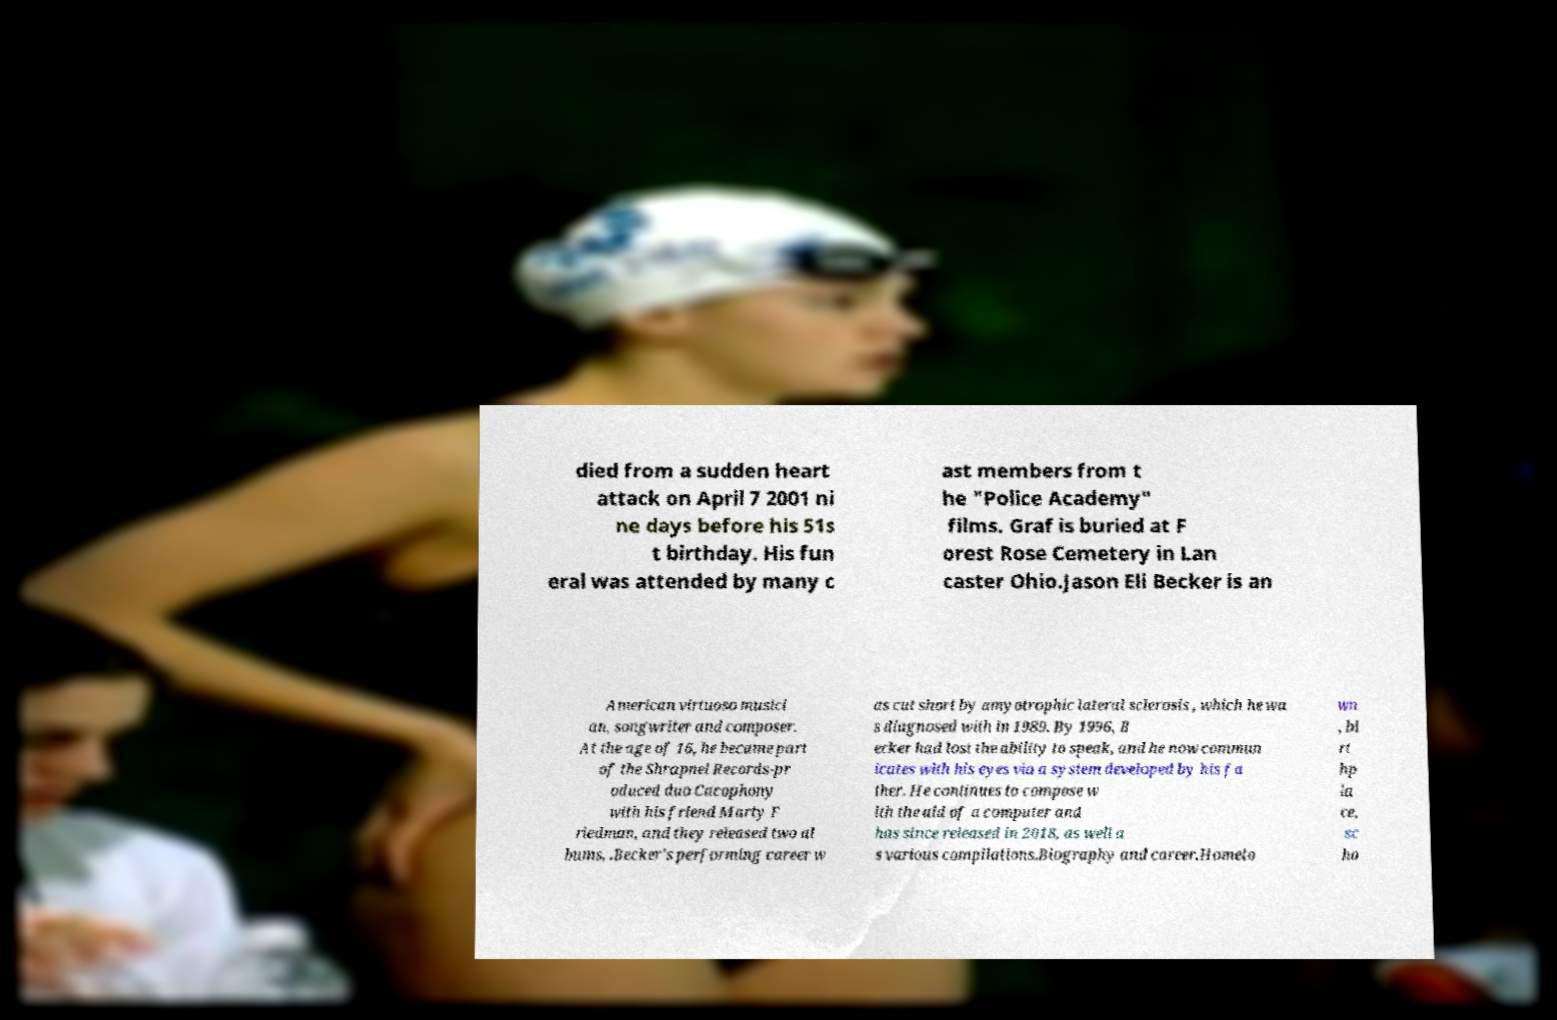What messages or text are displayed in this image? I need them in a readable, typed format. died from a sudden heart attack on April 7 2001 ni ne days before his 51s t birthday. His fun eral was attended by many c ast members from t he "Police Academy" films. Graf is buried at F orest Rose Cemetery in Lan caster Ohio.Jason Eli Becker is an American virtuoso musici an, songwriter and composer. At the age of 16, he became part of the Shrapnel Records-pr oduced duo Cacophony with his friend Marty F riedman, and they released two al bums, .Becker's performing career w as cut short by amyotrophic lateral sclerosis , which he wa s diagnosed with in 1989. By 1996, B ecker had lost the ability to speak, and he now commun icates with his eyes via a system developed by his fa ther. He continues to compose w ith the aid of a computer and has since released in 2018, as well a s various compilations.Biography and career.Hometo wn , bi rt hp la ce, sc ho 